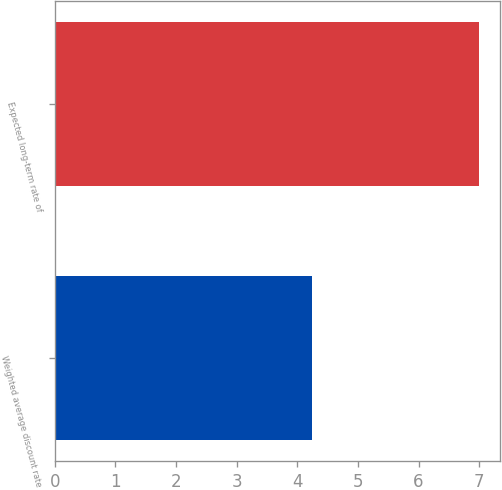<chart> <loc_0><loc_0><loc_500><loc_500><bar_chart><fcel>Weighted average discount rate<fcel>Expected long-term rate of<nl><fcel>4.25<fcel>7<nl></chart> 